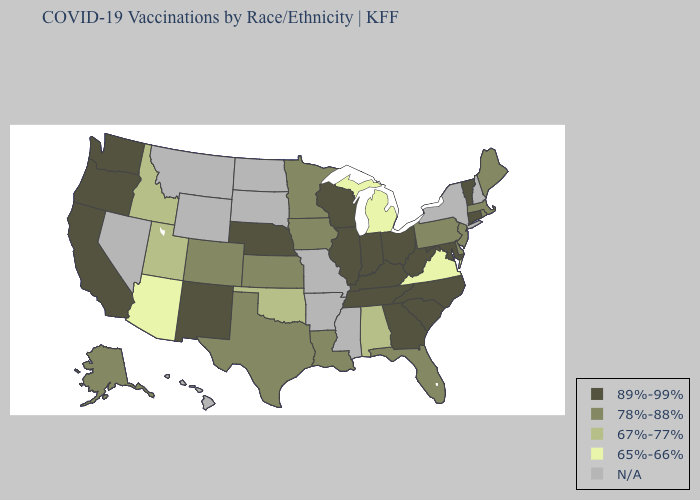Does Vermont have the lowest value in the Northeast?
Give a very brief answer. No. What is the highest value in the USA?
Concise answer only. 89%-99%. Name the states that have a value in the range 89%-99%?
Quick response, please. California, Connecticut, Georgia, Illinois, Indiana, Kentucky, Maryland, Nebraska, New Mexico, North Carolina, Ohio, Oregon, South Carolina, Tennessee, Vermont, Washington, West Virginia, Wisconsin. Which states have the lowest value in the USA?
Keep it brief. Arizona, Michigan, Virginia. How many symbols are there in the legend?
Concise answer only. 5. Which states have the lowest value in the USA?
Be succinct. Arizona, Michigan, Virginia. Does Minnesota have the highest value in the USA?
Concise answer only. No. Does Kansas have the highest value in the MidWest?
Keep it brief. No. Does Virginia have the lowest value in the USA?
Short answer required. Yes. What is the value of Colorado?
Keep it brief. 78%-88%. Which states have the lowest value in the USA?
Concise answer only. Arizona, Michigan, Virginia. Does the first symbol in the legend represent the smallest category?
Concise answer only. No. Which states have the lowest value in the MidWest?
Write a very short answer. Michigan. What is the value of Nevada?
Short answer required. N/A. 